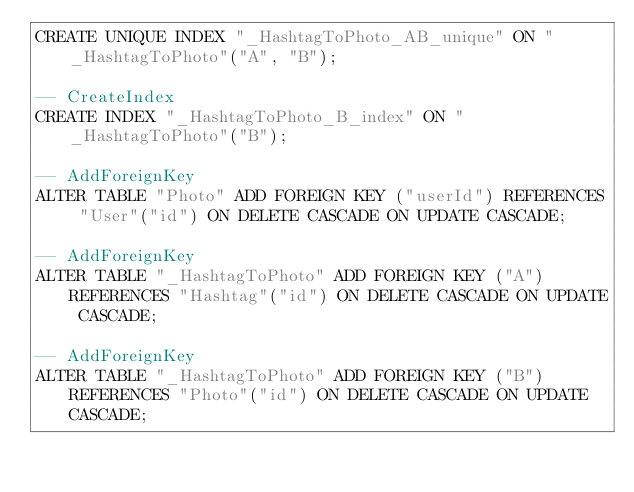<code> <loc_0><loc_0><loc_500><loc_500><_SQL_>CREATE UNIQUE INDEX "_HashtagToPhoto_AB_unique" ON "_HashtagToPhoto"("A", "B");

-- CreateIndex
CREATE INDEX "_HashtagToPhoto_B_index" ON "_HashtagToPhoto"("B");

-- AddForeignKey
ALTER TABLE "Photo" ADD FOREIGN KEY ("userId") REFERENCES "User"("id") ON DELETE CASCADE ON UPDATE CASCADE;

-- AddForeignKey
ALTER TABLE "_HashtagToPhoto" ADD FOREIGN KEY ("A") REFERENCES "Hashtag"("id") ON DELETE CASCADE ON UPDATE CASCADE;

-- AddForeignKey
ALTER TABLE "_HashtagToPhoto" ADD FOREIGN KEY ("B") REFERENCES "Photo"("id") ON DELETE CASCADE ON UPDATE CASCADE;
</code> 